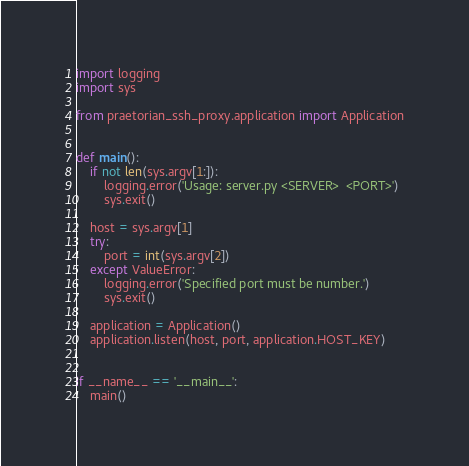Convert code to text. <code><loc_0><loc_0><loc_500><loc_500><_Python_>import logging
import sys

from praetorian_ssh_proxy.application import Application


def main():
    if not len(sys.argv[1:]):
        logging.error('Usage: server.py <SERVER>  <PORT>')
        sys.exit()

    host = sys.argv[1]
    try:
        port = int(sys.argv[2])
    except ValueError:
        logging.error('Specified port must be number.')
        sys.exit()

    application = Application()
    application.listen(host, port, application.HOST_KEY)


if __name__ == '__main__':
    main()
</code> 